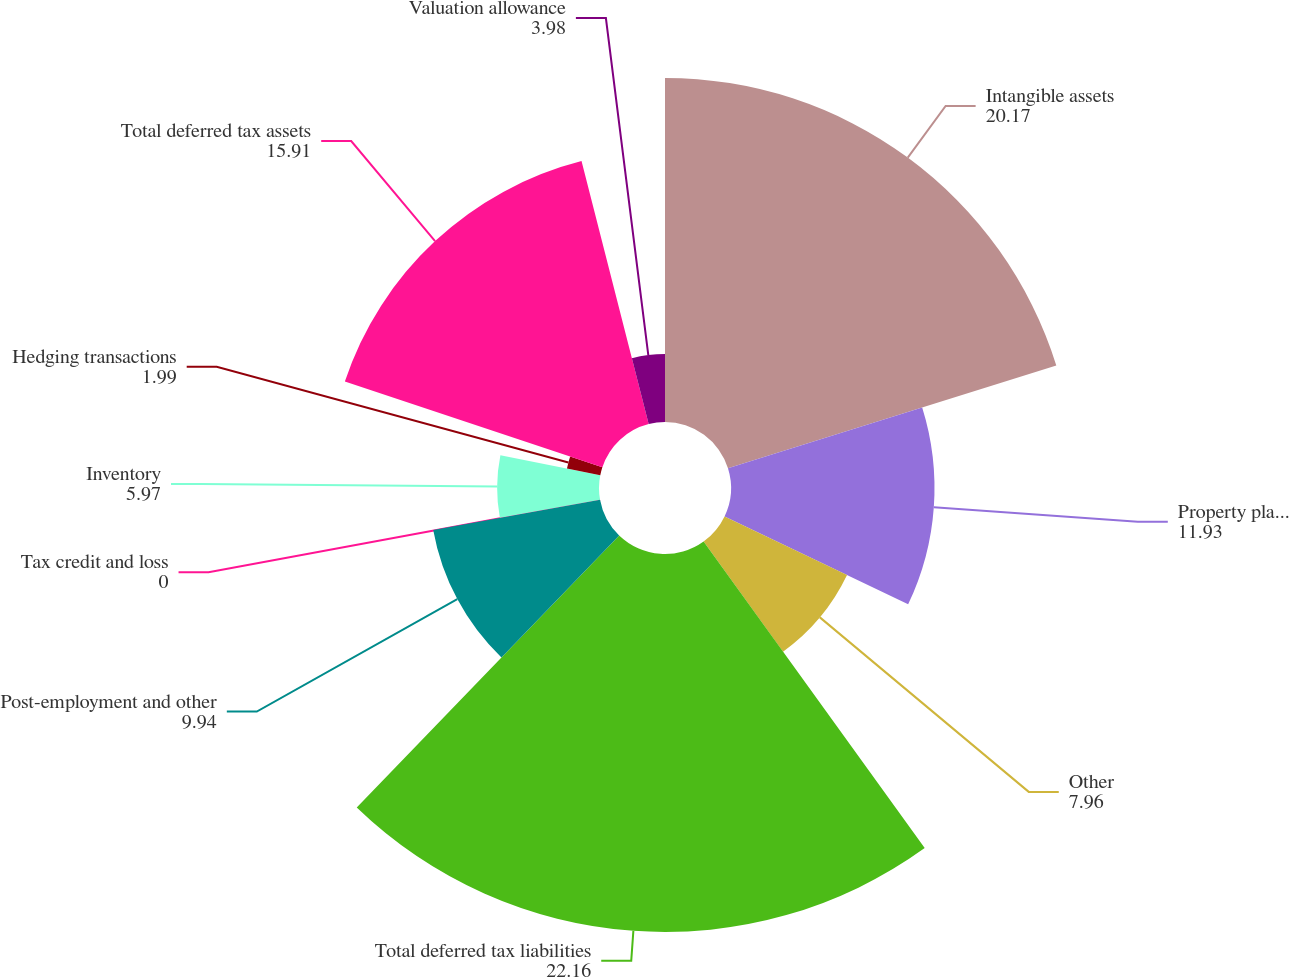Convert chart. <chart><loc_0><loc_0><loc_500><loc_500><pie_chart><fcel>Intangible assets<fcel>Property plant and equipment<fcel>Other<fcel>Total deferred tax liabilities<fcel>Post-employment and other<fcel>Tax credit and loss<fcel>Inventory<fcel>Hedging transactions<fcel>Total deferred tax assets<fcel>Valuation allowance<nl><fcel>20.17%<fcel>11.93%<fcel>7.96%<fcel>22.16%<fcel>9.94%<fcel>0.0%<fcel>5.97%<fcel>1.99%<fcel>15.91%<fcel>3.98%<nl></chart> 